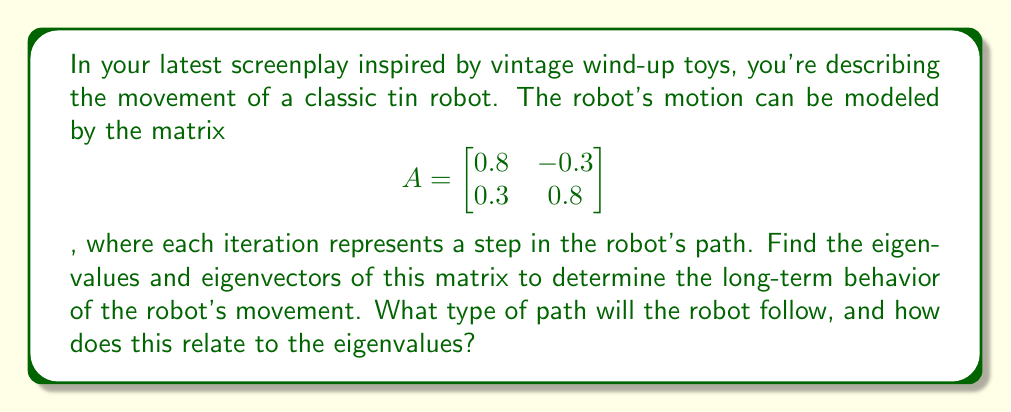Can you answer this question? 1) To find the eigenvalues, we solve the characteristic equation:
   $$det(A - \lambda I) = 0$$
   $$\begin{vmatrix} 0.8-\lambda & -0.3 \\ 0.3 & 0.8-\lambda \end{vmatrix} = 0$$
   $$(0.8-\lambda)^2 + 0.09 = 0$$
   $$\lambda^2 - 1.6\lambda + 0.73 = 0$$

2) Solving this quadratic equation:
   $$\lambda = \frac{1.6 \pm \sqrt{1.6^2 - 4(0.73)}}{2} = 0.8 \pm 0.3i$$

3) The eigenvalues are complex conjugates: $\lambda_1 = 0.8 + 0.3i$ and $\lambda_2 = 0.8 - 0.3i$

4) To find the eigenvectors, we solve $(A - \lambda I)v = 0$ for each eigenvalue:
   For $\lambda_1 = 0.8 + 0.3i$:
   $$\begin{bmatrix} -0.3i & -0.3 \\ 0.3 & -0.3i \end{bmatrix}\begin{bmatrix} v_1 \\ v_2 \end{bmatrix} = \begin{bmatrix} 0 \\ 0 \end{bmatrix}$$
   
   This gives us the eigenvector $v_1 = \begin{bmatrix} 1 \\ i \end{bmatrix}$

   For $\lambda_2 = 0.8 - 0.3i$, we get the conjugate eigenvector $v_2 = \begin{bmatrix} 1 \\ -i \end{bmatrix}$

5) The complex eigenvalues with magnitude 1 ($|\lambda| = \sqrt{0.8^2 + 0.3^2} = 1$) indicate that the robot's path will follow a circular or spiral pattern.

6) The real part of the eigenvalues (0.8) being less than 1 suggests that the spiral will gradually contract towards the origin.
Answer: The robot will follow a contracting spiral path towards the origin. 